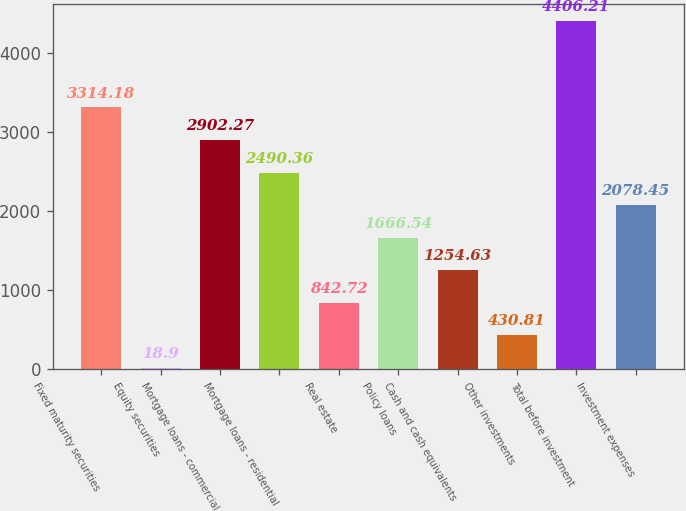<chart> <loc_0><loc_0><loc_500><loc_500><bar_chart><fcel>Fixed maturity securities<fcel>Equity securities<fcel>Mortgage loans - commercial<fcel>Mortgage loans - residential<fcel>Real estate<fcel>Policy loans<fcel>Cash and cash equivalents<fcel>Other investments<fcel>Total before investment<fcel>Investment expenses<nl><fcel>3314.18<fcel>18.9<fcel>2902.27<fcel>2490.36<fcel>842.72<fcel>1666.54<fcel>1254.63<fcel>430.81<fcel>4406.21<fcel>2078.45<nl></chart> 